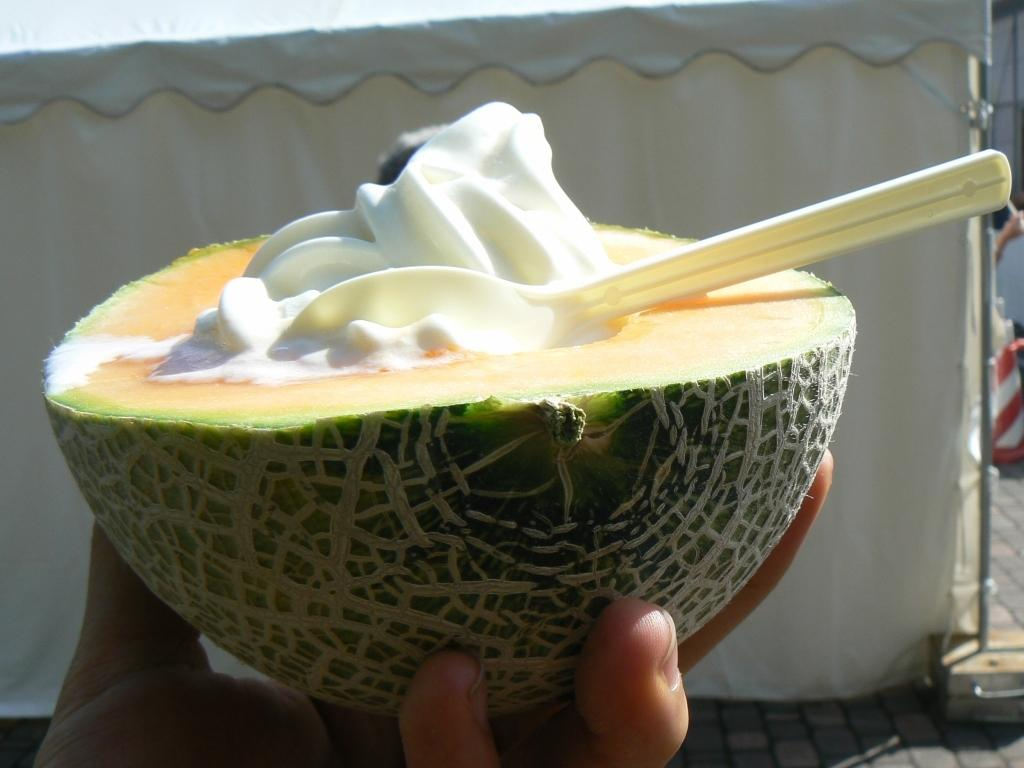What is the hand holding in the image? There is a hand holding a piece of musk melon in the image. What is inside the piece of musk melon? The piece of musk melon contains cream. What utensil is placed on the piece of musk melon? There is a spoon on the piece of musk melon. What can be seen in the background of the image? There is a tent visible in the background of the image. Who is teaching the class in the image? There is no class or teacher present in the image; it features a hand holding a piece of musk melon with cream and a spoon, and a tent in the background. 